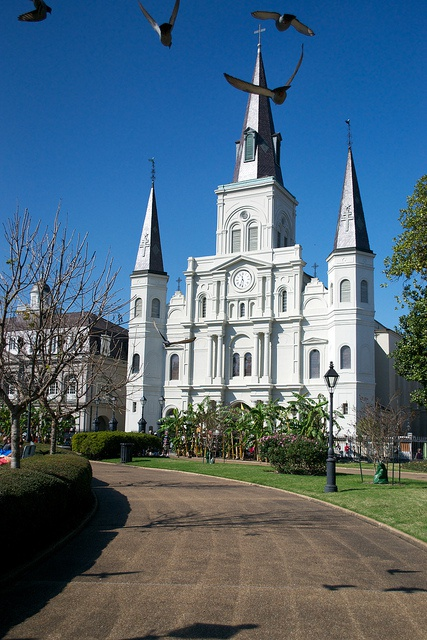Describe the objects in this image and their specific colors. I can see bird in darkblue, black, blue, and gray tones, bird in darkblue, black, and navy tones, clock in darkblue, white, darkgray, gray, and lightgray tones, bird in darkblue, black, gray, navy, and darkgray tones, and bird in darkblue, black, navy, and blue tones in this image. 